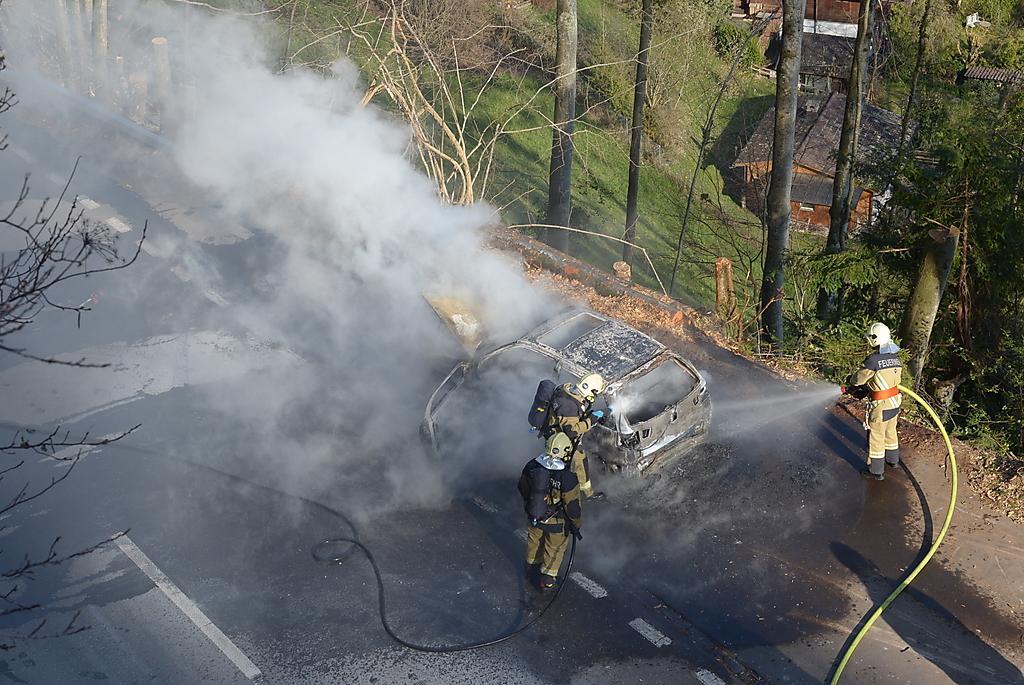In one or two sentences, can you explain what this image depicts? There are three people standing and holding pipes as we can see at the bottom of this image. We can see a car, road and stems of a tree at the bottom of this image. There are trees and houses at the top of this image. 